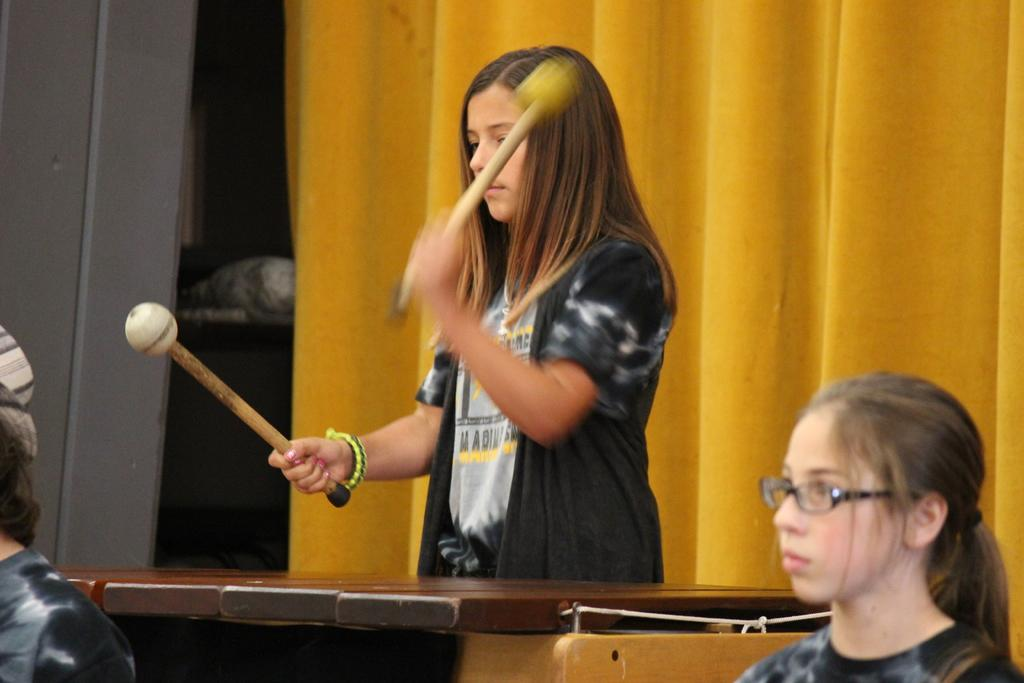Who is the main subject in the image? There is a girl in the image. What is the girl doing in the image? The girl is playing a musical instrument. What can be seen in the background of the image? There is a yellow curtain in the background of the image. What type of page can be seen turning in the image? There is no page present in the image; it features a girl playing a musical instrument with a yellow curtain in the background. 